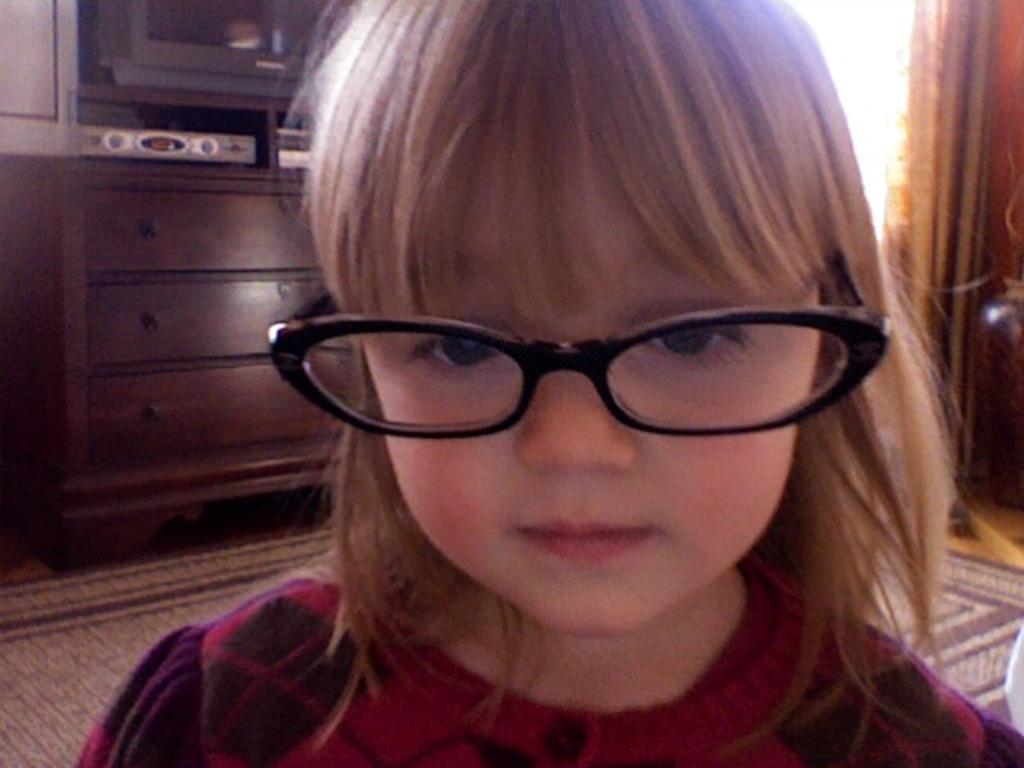Describe this image in one or two sentences. In this image in front there is a girl. Behind her there is a TV. There are few objects on the table. At the bottom of the image there is a mat on the floor. On the right side of the image there is a curtain. 